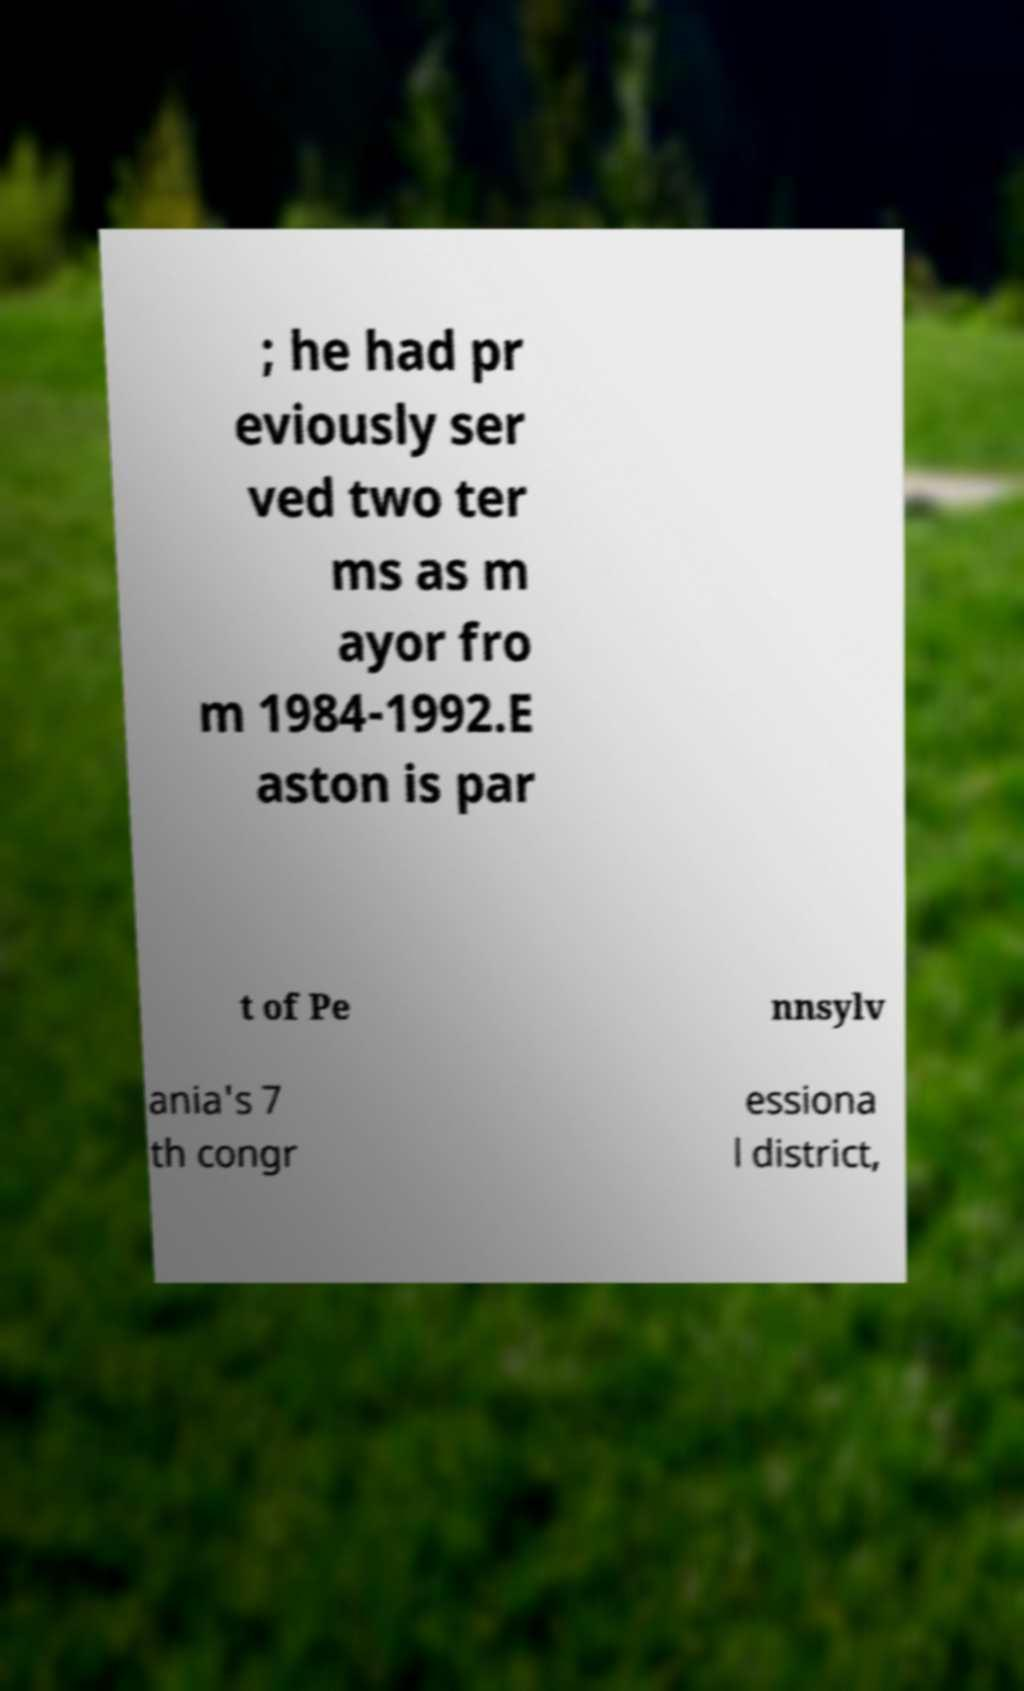I need the written content from this picture converted into text. Can you do that? ; he had pr eviously ser ved two ter ms as m ayor fro m 1984-1992.E aston is par t of Pe nnsylv ania's 7 th congr essiona l district, 